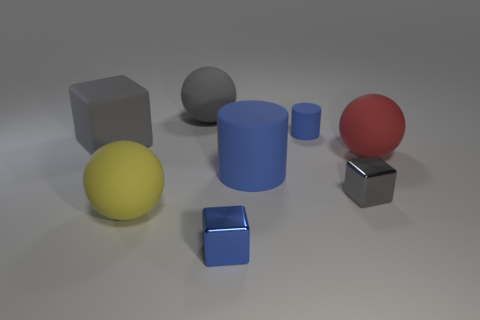What shape is the small metallic object that is the same color as the large rubber cylinder? cube 